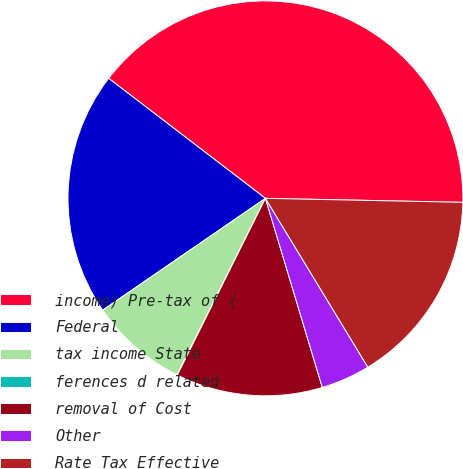Convert chart to OTSL. <chart><loc_0><loc_0><loc_500><loc_500><pie_chart><fcel>income) Pre-tax of (<fcel>Federal<fcel>tax income State<fcel>ferences d related<fcel>removal of Cost<fcel>Other<fcel>Rate Tax Effective<nl><fcel>39.93%<fcel>19.98%<fcel>8.02%<fcel>0.04%<fcel>12.01%<fcel>4.03%<fcel>16.0%<nl></chart> 